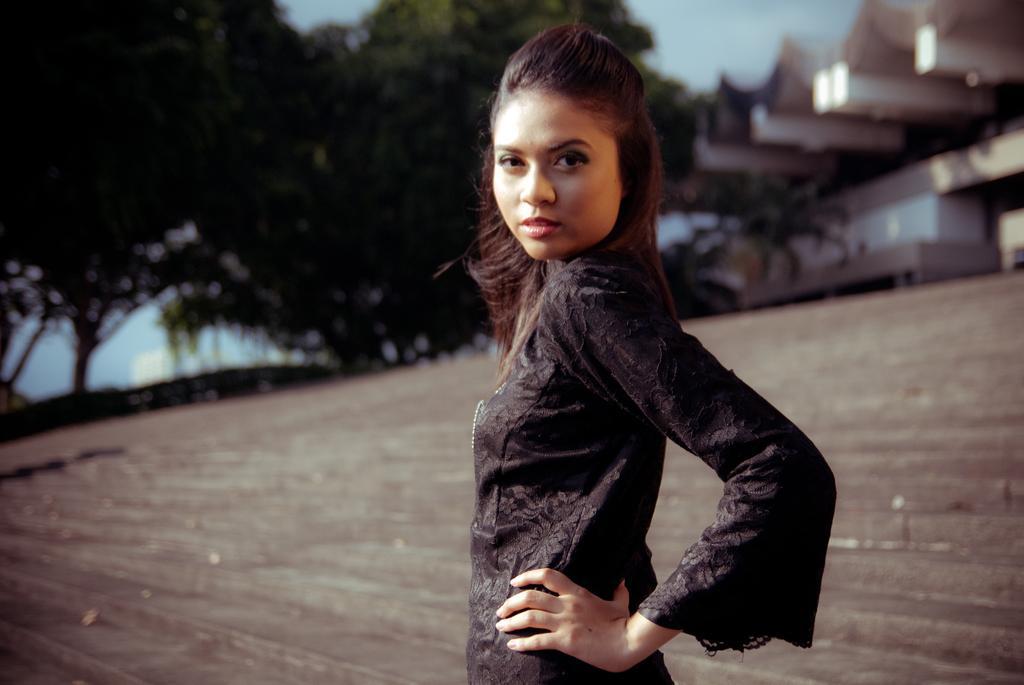Describe this image in one or two sentences. In the center of the image, we can see a lady on the ground and in the background, there are trees and buildings. 